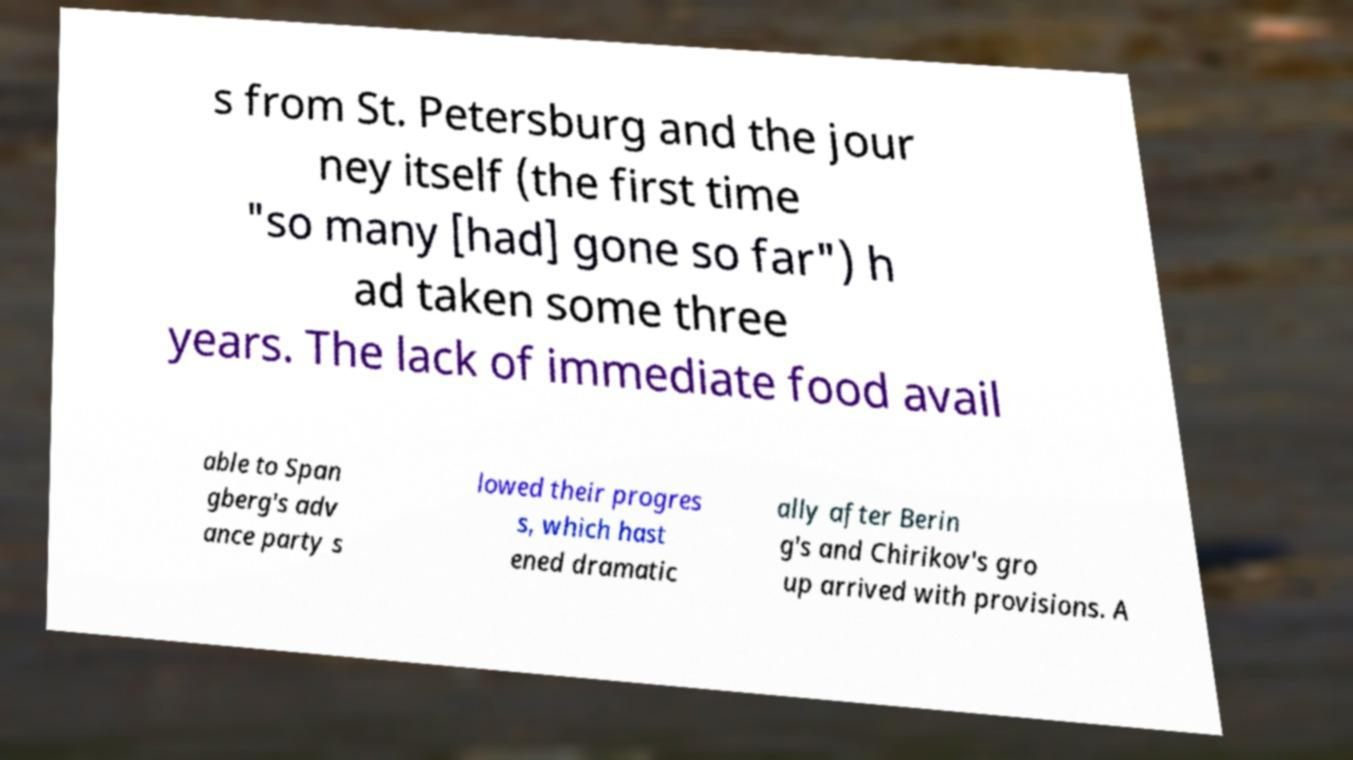Could you assist in decoding the text presented in this image and type it out clearly? s from St. Petersburg and the jour ney itself (the first time "so many [had] gone so far") h ad taken some three years. The lack of immediate food avail able to Span gberg's adv ance party s lowed their progres s, which hast ened dramatic ally after Berin g's and Chirikov's gro up arrived with provisions. A 